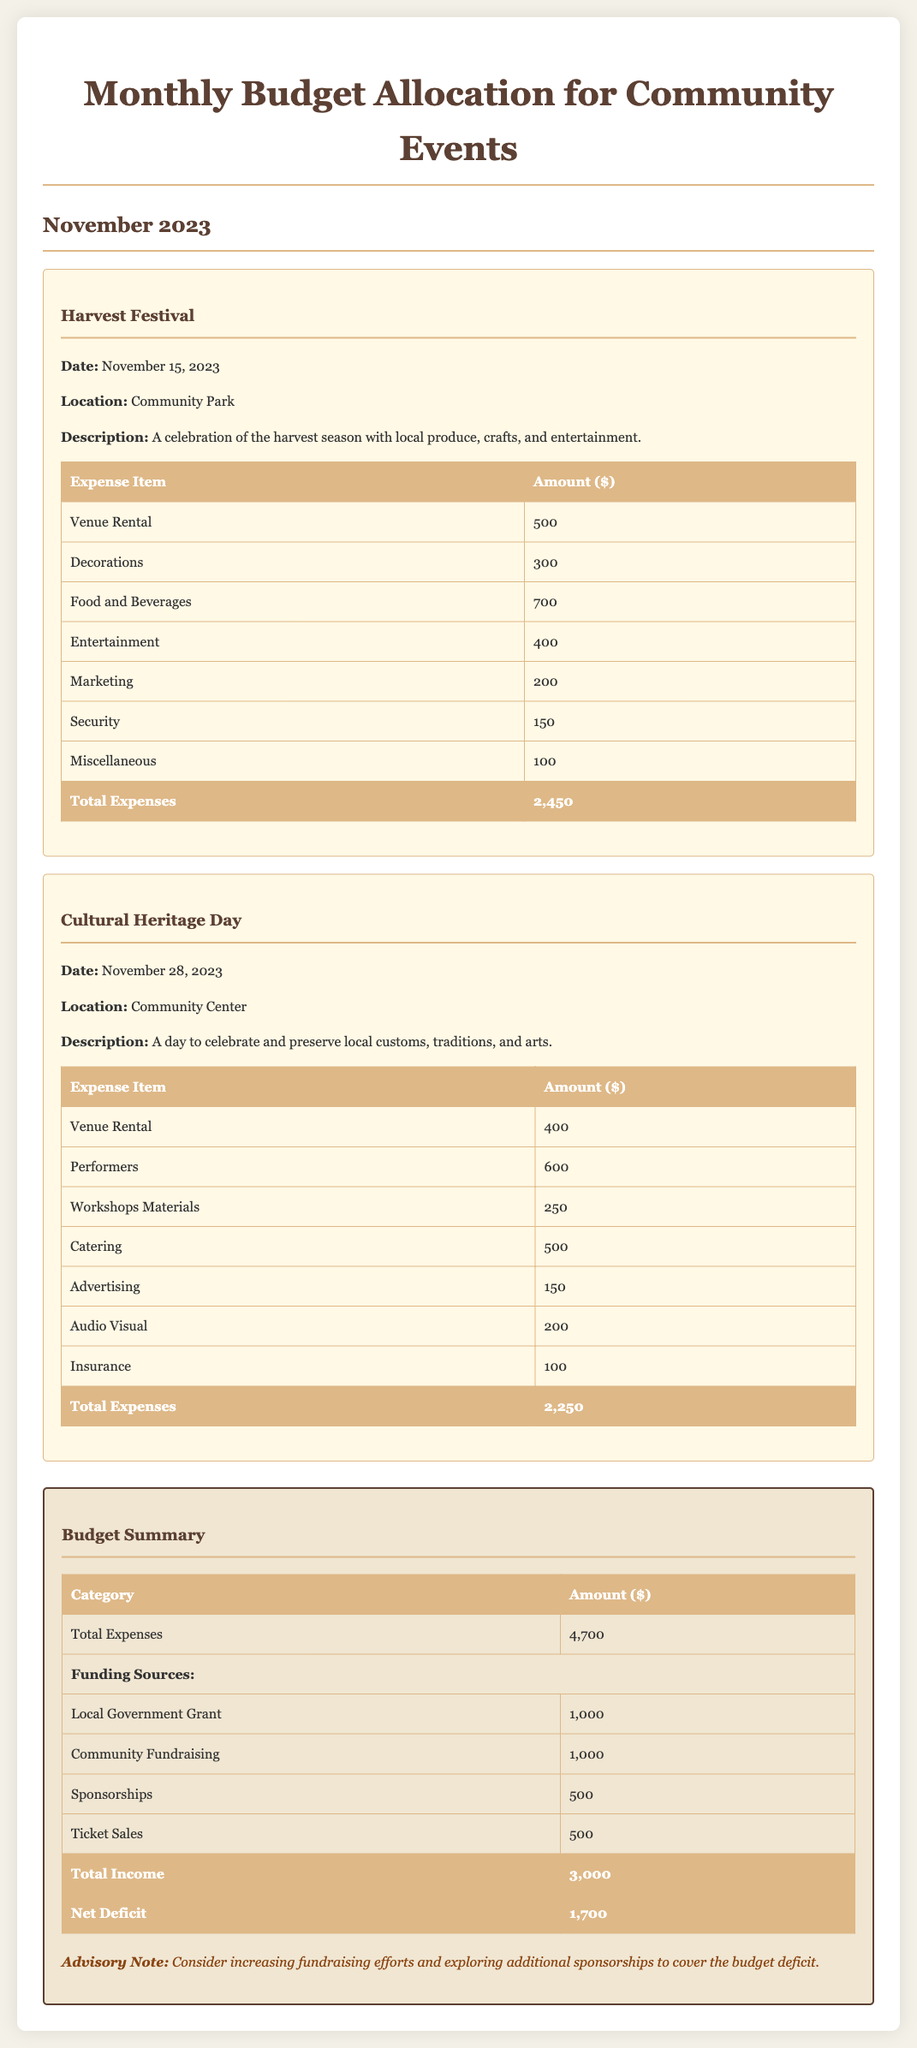What is the total amount allocated for the Harvest Festival? The total expenses for the Harvest Festival are detailed in the table, which lists an amount of $2450.
Answer: $2450 What is the date of the Cultural Heritage Day? The date of the Cultural Heritage Day can be found in its description, which states it is on November 28, 2023.
Answer: November 28, 2023 How much is budgeted for Food and Beverages in the Harvest Festival? The detailed breakdown of expenses for the Harvest Festival includes a line for Food and Beverages, which amounts to $700.
Answer: $700 What is the total deficit outlined in the budget summary? The budget summary indicates that the total net deficit is calculated as $1700.
Answer: $1700 How much funding comes from Community Fundraising? The funding sources section lists Community Fundraising with a total of $1000.
Answer: $1000 What is the total expense amount for both events combined? The summary table shows the total expenses for both events, which sums up to $4700.
Answer: $4700 What is the total amount of funding from Sponsorships? The funding sources table provides the amount for Sponsorships, which is shown to be $500.
Answer: $500 What category has the highest expense in the Cultural Heritage Day event? Reviewing the expense items, the highest category listed is Performers at $600.
Answer: Performers What is the purpose of the Harvest Festival? The description of the Harvest Festival outlines it as a celebration of the harvest season.
Answer: Celebration of the harvest season 